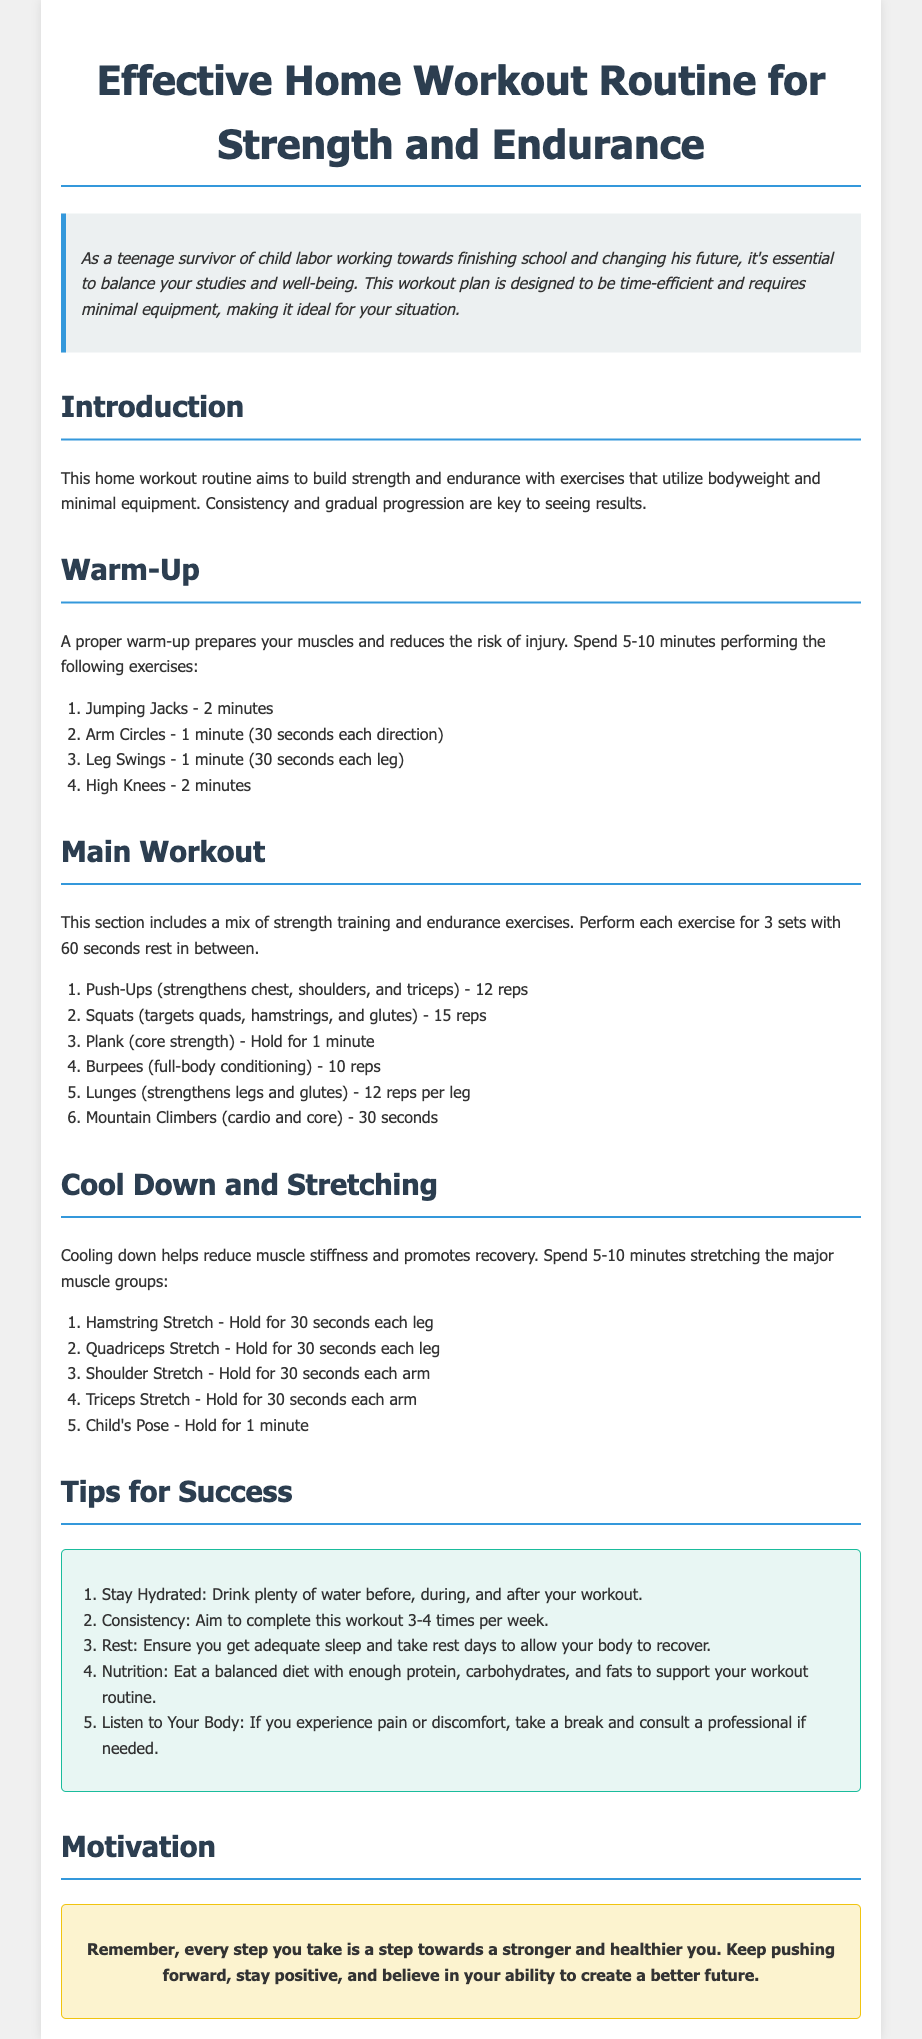What is the title of the document? The title of the document is presented at the top of the page, indicating the main focus of the content.
Answer: Effective Home Workout Routine for Strength and Endurance How long should the warm-up last? The document specifies the duration for the warm-up section, stating how much time you should spend doing it.
Answer: 5-10 minutes How many sets are recommended for each main workout exercise? The main workout section includes a guideline on how many sets to perform, which is a critical aspect of workout planning.
Answer: 3 sets What is the rep count for Push-Ups? The main workout details the number of repetitions to perform for each exercise, specifically for Push-Ups.
Answer: 12 reps What is one tip mentioned for success? The Tips for Success section includes multiple recommendations, and the question seeks one example to illustrate the guidance given.
Answer: Stay Hydrated How long should the Child's Pose stretching be held? The Cool Down and Stretching section specifies the duration for each stretch, focusing on this particular stretching exercise.
Answer: 1 minute What is the purpose of cooling down? The introduction to the Cool Down and Stretching section provides insight into its significance for the body after exercising.
Answer: Reduces muscle stiffness How many times per week should the workout be completed? The Tips for Success section advises on the frequency of completing the workout, which is critical for achieving fitness goals.
Answer: 3-4 times per week 